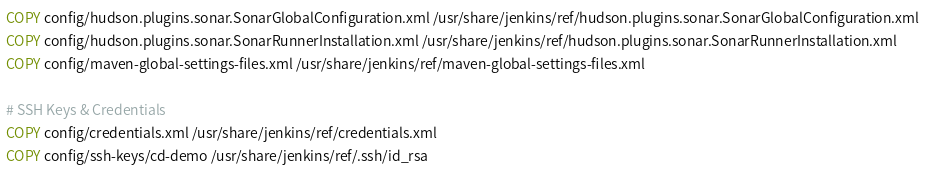Convert code to text. <code><loc_0><loc_0><loc_500><loc_500><_Dockerfile_>COPY config/hudson.plugins.sonar.SonarGlobalConfiguration.xml /usr/share/jenkins/ref/hudson.plugins.sonar.SonarGlobalConfiguration.xml
COPY config/hudson.plugins.sonar.SonarRunnerInstallation.xml /usr/share/jenkins/ref/hudson.plugins.sonar.SonarRunnerInstallation.xml
COPY config/maven-global-settings-files.xml /usr/share/jenkins/ref/maven-global-settings-files.xml

# SSH Keys & Credentials
COPY config/credentials.xml /usr/share/jenkins/ref/credentials.xml
COPY config/ssh-keys/cd-demo /usr/share/jenkins/ref/.ssh/id_rsa</code> 